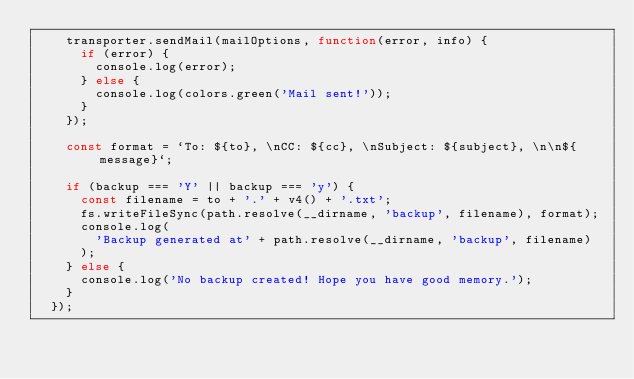<code> <loc_0><loc_0><loc_500><loc_500><_JavaScript_>    transporter.sendMail(mailOptions, function(error, info) {
      if (error) {
        console.log(error);
      } else {
        console.log(colors.green('Mail sent!'));
      }
    });

    const format = `To: ${to}, \nCC: ${cc}, \nSubject: ${subject}, \n\n${message}`;

    if (backup === 'Y' || backup === 'y') {
      const filename = to + '.' + v4() + '.txt';
      fs.writeFileSync(path.resolve(__dirname, 'backup', filename), format);
      console.log(
        'Backup generated at' + path.resolve(__dirname, 'backup', filename)
      );
    } else {
      console.log('No backup created! Hope you have good memory.');
    }
  });
</code> 